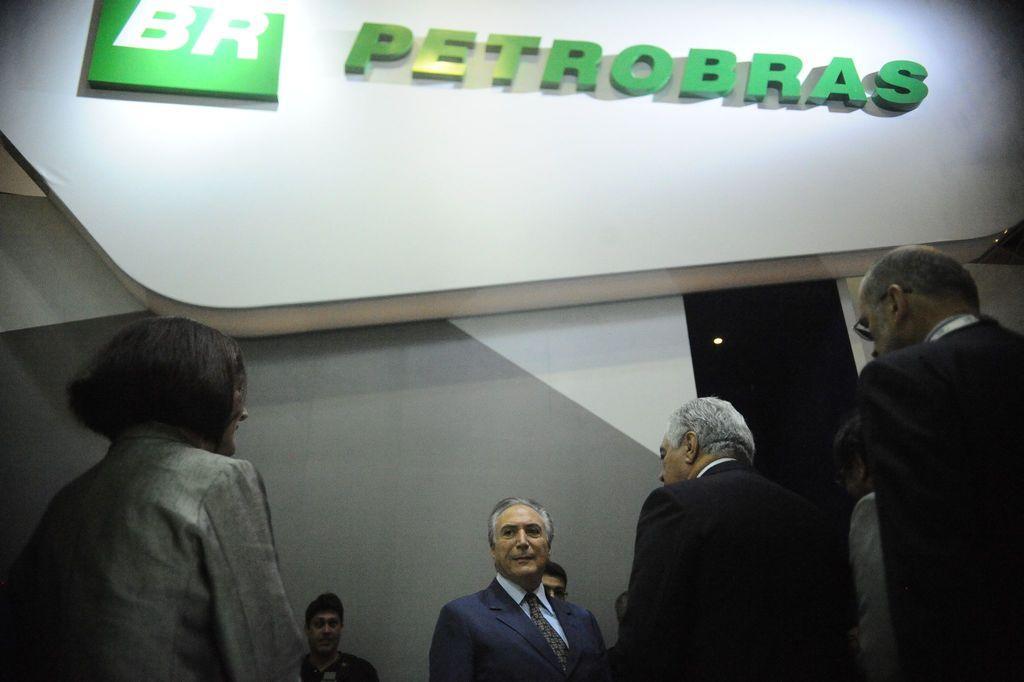In one or two sentences, can you explain what this image depicts? In this image there are group of persons, there is a wall behind the person, there is a light, there is text on the wall. 